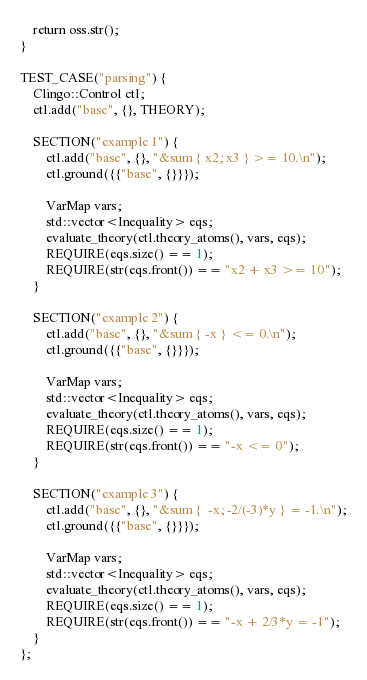Convert code to text. <code><loc_0><loc_0><loc_500><loc_500><_C++_>    return oss.str();
}

TEST_CASE("parsing") {
    Clingo::Control ctl;
    ctl.add("base", {}, THEORY);

    SECTION("example 1") {
        ctl.add("base", {}, "&sum { x2; x3 } >= 10.\n");
        ctl.ground({{"base", {}}});

        VarMap vars;
        std::vector<Inequality> eqs;
        evaluate_theory(ctl.theory_atoms(), vars, eqs);
        REQUIRE(eqs.size() == 1);
        REQUIRE(str(eqs.front()) == "x2 + x3 >= 10");
    }

    SECTION("example 2") {
        ctl.add("base", {}, "&sum { -x } <= 0.\n");
        ctl.ground({{"base", {}}});

        VarMap vars;
        std::vector<Inequality> eqs;
        evaluate_theory(ctl.theory_atoms(), vars, eqs);
        REQUIRE(eqs.size() == 1);
        REQUIRE(str(eqs.front()) == "-x <= 0");
    }

    SECTION("example 3") {
        ctl.add("base", {}, "&sum {  -x; -2/(-3)*y } = -1.\n");
        ctl.ground({{"base", {}}});

        VarMap vars;
        std::vector<Inequality> eqs;
        evaluate_theory(ctl.theory_atoms(), vars, eqs);
        REQUIRE(eqs.size() == 1);
        REQUIRE(str(eqs.front()) == "-x + 2/3*y = -1");
    }
};

</code> 